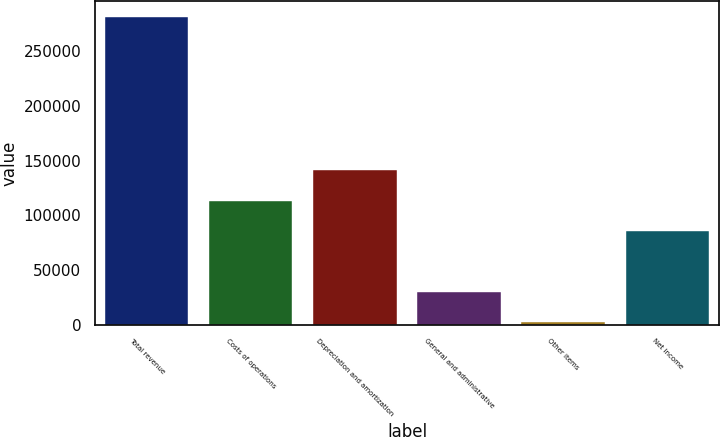Convert chart to OTSL. <chart><loc_0><loc_0><loc_500><loc_500><bar_chart><fcel>Total revenue<fcel>Costs of operations<fcel>Depreciation and amortization<fcel>General and administrative<fcel>Other items<fcel>Net income<nl><fcel>281843<fcel>113342<fcel>141336<fcel>29892.5<fcel>1898<fcel>85347<nl></chart> 